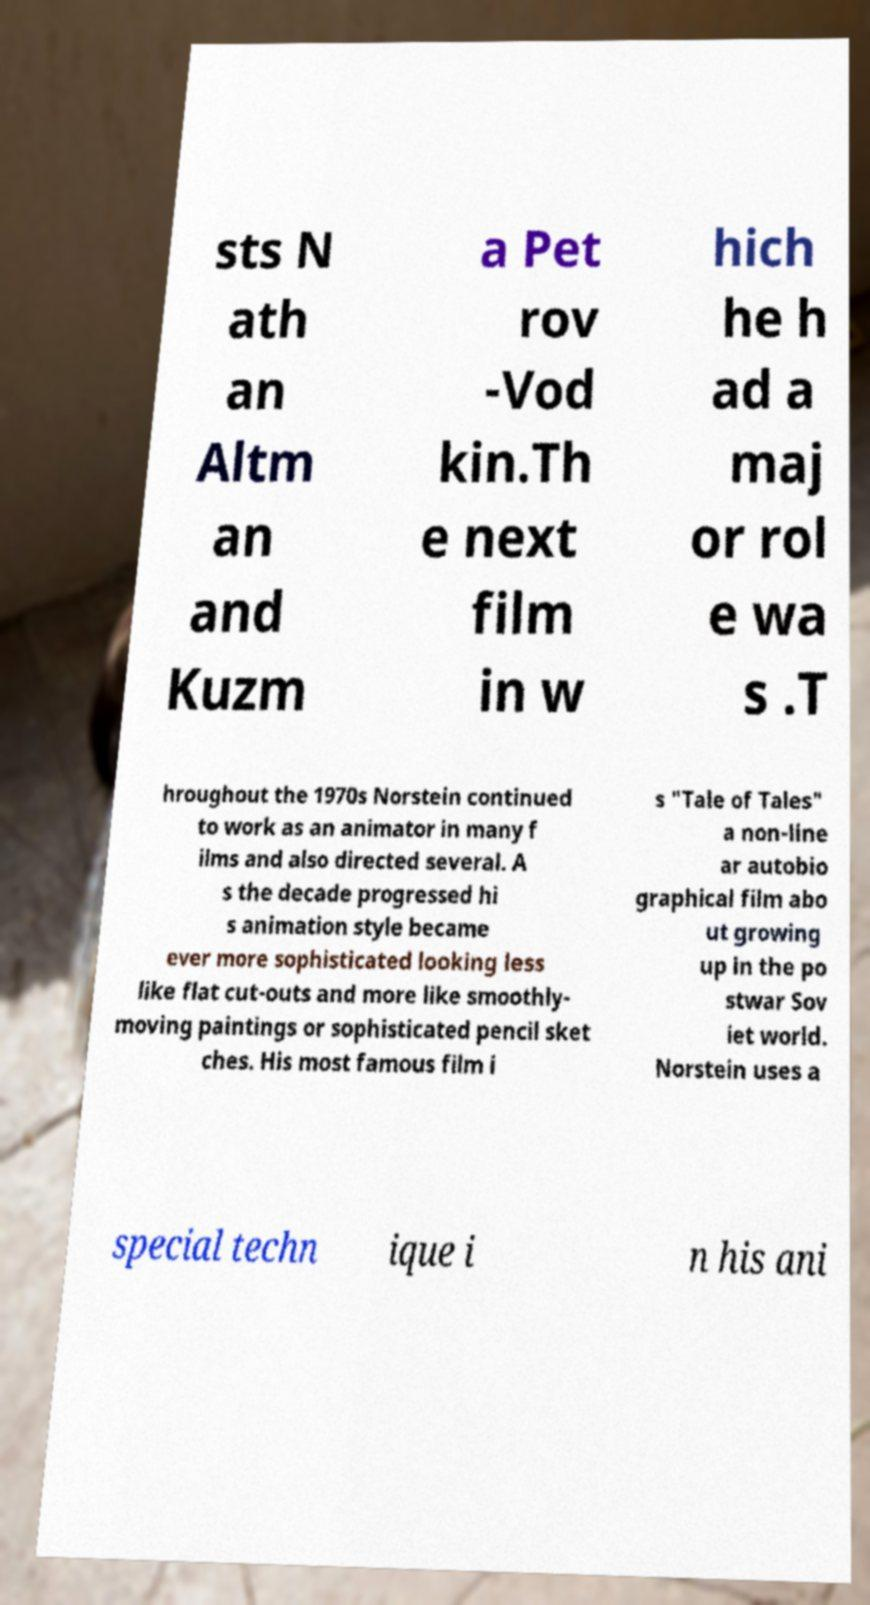Could you assist in decoding the text presented in this image and type it out clearly? sts N ath an Altm an and Kuzm a Pet rov -Vod kin.Th e next film in w hich he h ad a maj or rol e wa s .T hroughout the 1970s Norstein continued to work as an animator in many f ilms and also directed several. A s the decade progressed hi s animation style became ever more sophisticated looking less like flat cut-outs and more like smoothly- moving paintings or sophisticated pencil sket ches. His most famous film i s "Tale of Tales" a non-line ar autobio graphical film abo ut growing up in the po stwar Sov iet world. Norstein uses a special techn ique i n his ani 